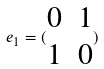<formula> <loc_0><loc_0><loc_500><loc_500>e _ { 1 } = ( \begin{matrix} 0 & 1 \\ 1 & 0 \end{matrix} )</formula> 